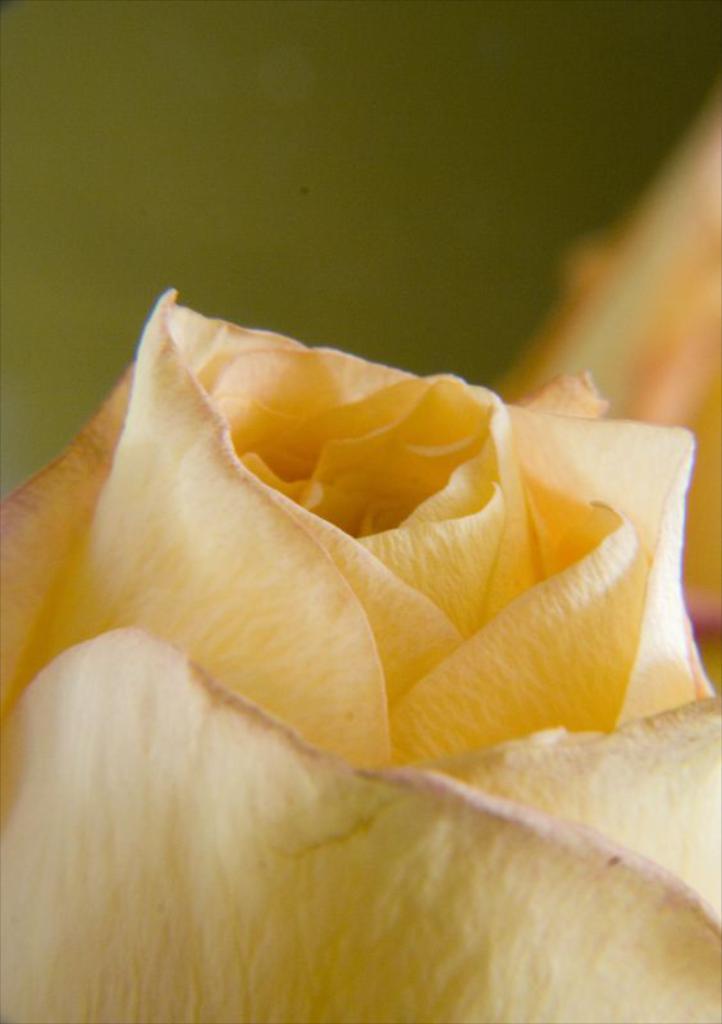Can you describe this image briefly? In the foreground of this picture we can see a yellow color flower. In the background we can see some other objects. 